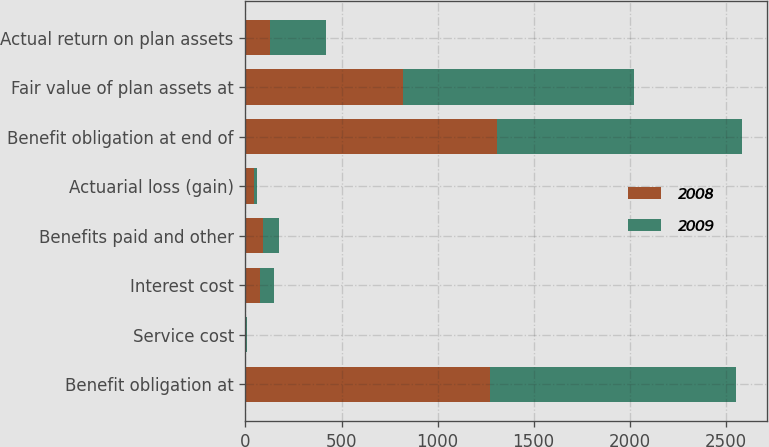<chart> <loc_0><loc_0><loc_500><loc_500><stacked_bar_chart><ecel><fcel>Benefit obligation at<fcel>Service cost<fcel>Interest cost<fcel>Benefits paid and other<fcel>Actuarial loss (gain)<fcel>Benefit obligation at end of<fcel>Fair value of plan assets at<fcel>Actual return on plan assets<nl><fcel>2008<fcel>1275.1<fcel>2<fcel>75.9<fcel>90.5<fcel>46.8<fcel>1309.3<fcel>821<fcel>125.2<nl><fcel>2009<fcel>1276.8<fcel>7.3<fcel>72.7<fcel>85.5<fcel>11.2<fcel>1275.1<fcel>1200.5<fcel>294.5<nl></chart> 